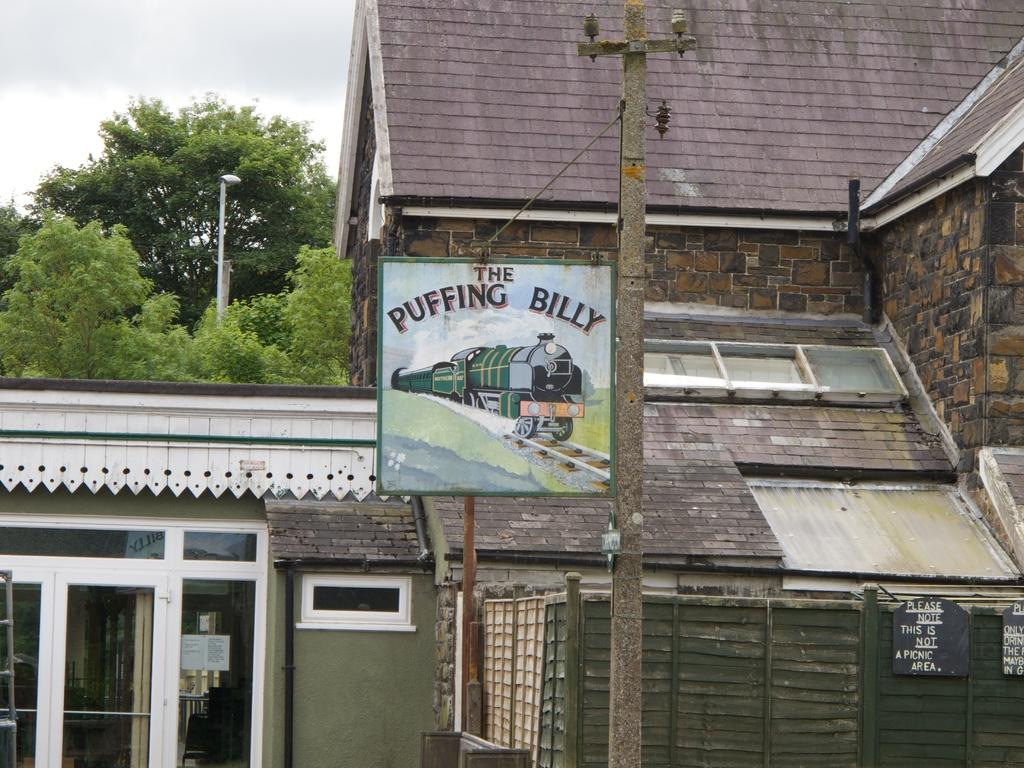What type of structure is present in the image? There is a building in the image. What objects can be seen near the building? There are boards and poles in the image. What can be seen in the background of the image? There are trees and the sky visible in the background of the image. What type of guitar is being played by the person in the image? There is no person or guitar present in the image. 